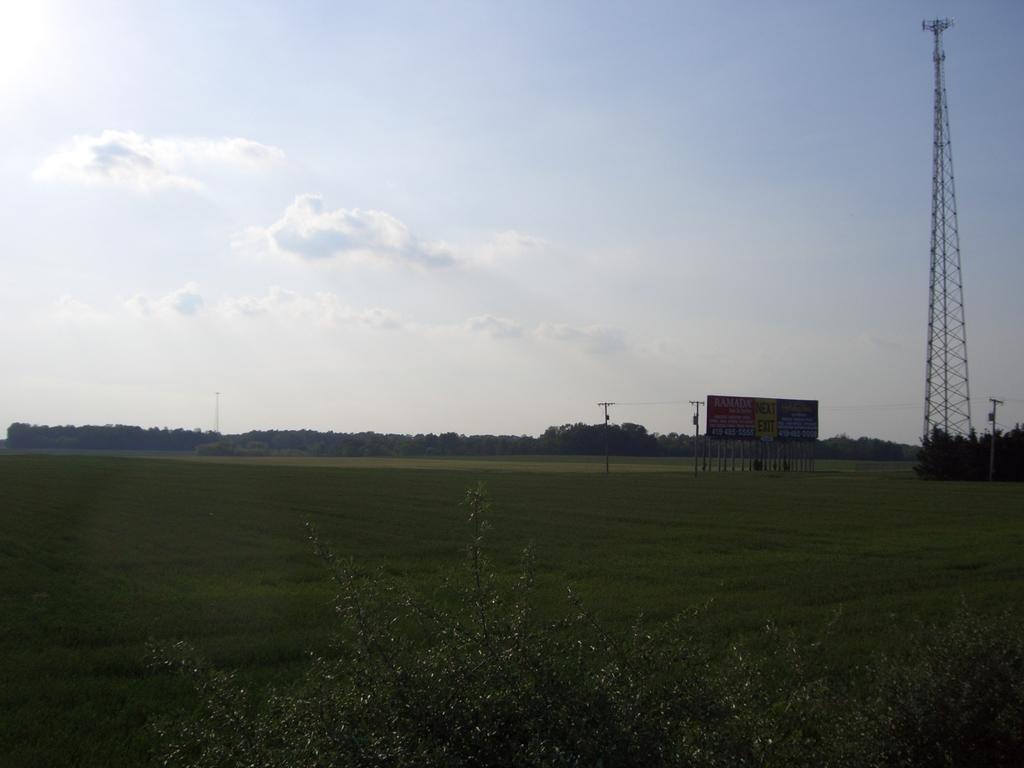Describe this image in one or two sentences. In this image I can see plants and grass in green color, background I can see a tower, few electric poles and a board attached the pole and the sky is in white color. 